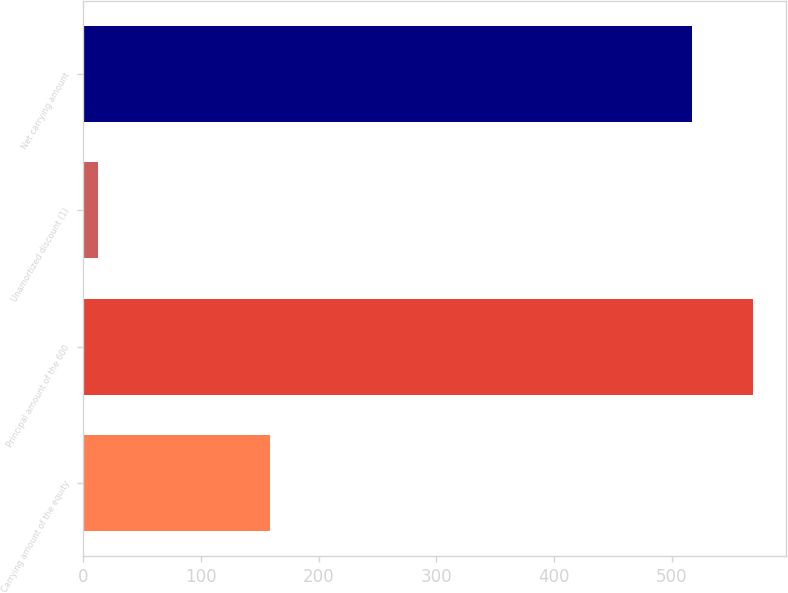Convert chart. <chart><loc_0><loc_0><loc_500><loc_500><bar_chart><fcel>Carrying amount of the equity<fcel>Principal amount of the 600<fcel>Unamortized discount (1)<fcel>Net carrying amount<nl><fcel>159<fcel>568.7<fcel>13<fcel>517<nl></chart> 